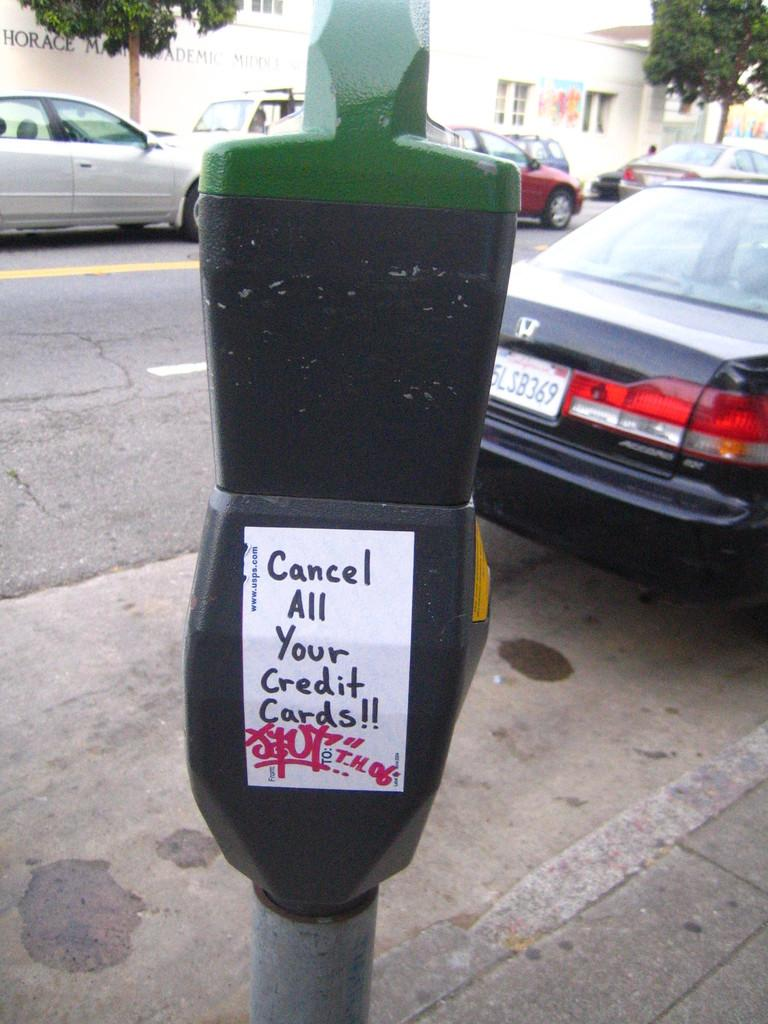<image>
Summarize the visual content of the image. A parking meter with a sing advising to cancel all of your credit cards 